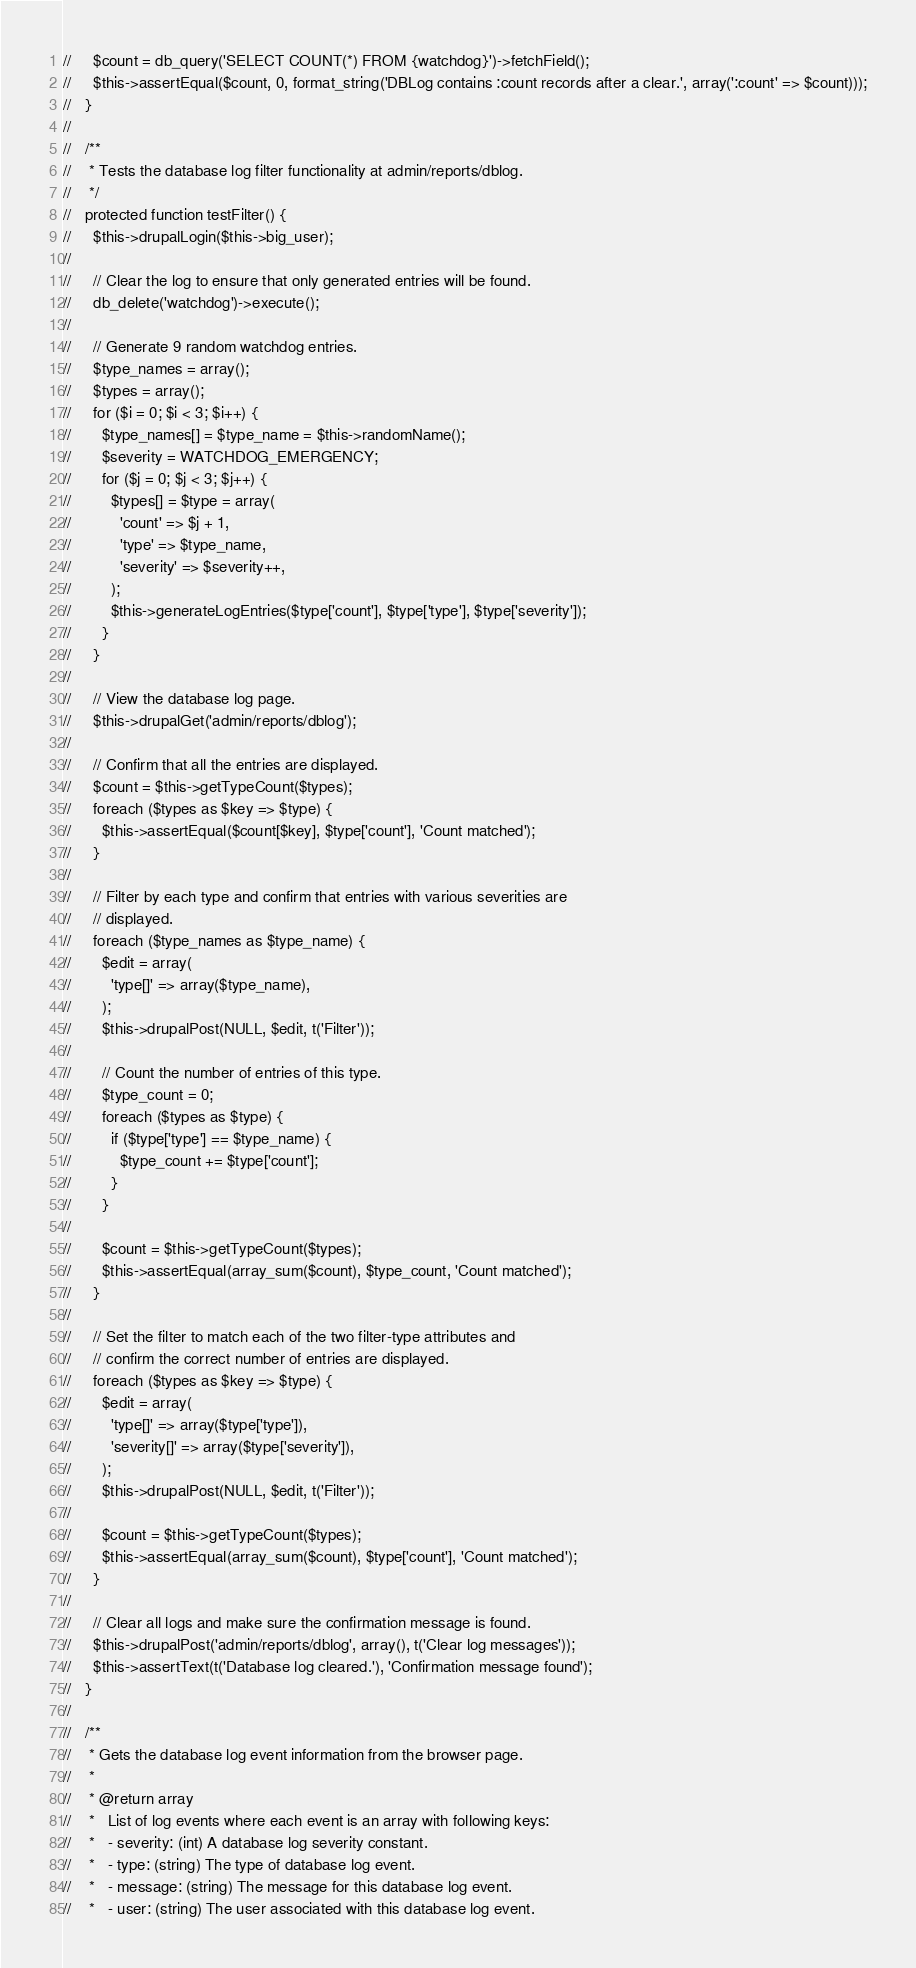<code> <loc_0><loc_0><loc_500><loc_500><_PHP_>//     $count = db_query('SELECT COUNT(*) FROM {watchdog}')->fetchField();
//     $this->assertEqual($count, 0, format_string('DBLog contains :count records after a clear.', array(':count' => $count)));
//   }
// 
//   /**
//    * Tests the database log filter functionality at admin/reports/dblog.
//    */
//   protected function testFilter() {
//     $this->drupalLogin($this->big_user);
// 
//     // Clear the log to ensure that only generated entries will be found.
//     db_delete('watchdog')->execute();
// 
//     // Generate 9 random watchdog entries.
//     $type_names = array();
//     $types = array();
//     for ($i = 0; $i < 3; $i++) {
//       $type_names[] = $type_name = $this->randomName();
//       $severity = WATCHDOG_EMERGENCY;
//       for ($j = 0; $j < 3; $j++) {
//         $types[] = $type = array(
//           'count' => $j + 1,
//           'type' => $type_name,
//           'severity' => $severity++,
//         );
//         $this->generateLogEntries($type['count'], $type['type'], $type['severity']);
//       }
//     }
// 
//     // View the database log page.
//     $this->drupalGet('admin/reports/dblog');
// 
//     // Confirm that all the entries are displayed.
//     $count = $this->getTypeCount($types);
//     foreach ($types as $key => $type) {
//       $this->assertEqual($count[$key], $type['count'], 'Count matched');
//     }
// 
//     // Filter by each type and confirm that entries with various severities are
//     // displayed.
//     foreach ($type_names as $type_name) {
//       $edit = array(
//         'type[]' => array($type_name),
//       );
//       $this->drupalPost(NULL, $edit, t('Filter'));
// 
//       // Count the number of entries of this type.
//       $type_count = 0;
//       foreach ($types as $type) {
//         if ($type['type'] == $type_name) {
//           $type_count += $type['count'];
//         }
//       }
// 
//       $count = $this->getTypeCount($types);
//       $this->assertEqual(array_sum($count), $type_count, 'Count matched');
//     }
// 
//     // Set the filter to match each of the two filter-type attributes and
//     // confirm the correct number of entries are displayed.
//     foreach ($types as $key => $type) {
//       $edit = array(
//         'type[]' => array($type['type']),
//         'severity[]' => array($type['severity']),
//       );
//       $this->drupalPost(NULL, $edit, t('Filter'));
// 
//       $count = $this->getTypeCount($types);
//       $this->assertEqual(array_sum($count), $type['count'], 'Count matched');
//     }
// 
//     // Clear all logs and make sure the confirmation message is found.
//     $this->drupalPost('admin/reports/dblog', array(), t('Clear log messages'));
//     $this->assertText(t('Database log cleared.'), 'Confirmation message found');
//   }
// 
//   /**
//    * Gets the database log event information from the browser page.
//    *
//    * @return array
//    *   List of log events where each event is an array with following keys:
//    *   - severity: (int) A database log severity constant.
//    *   - type: (string) The type of database log event.
//    *   - message: (string) The message for this database log event.
//    *   - user: (string) The user associated with this database log event.</code> 